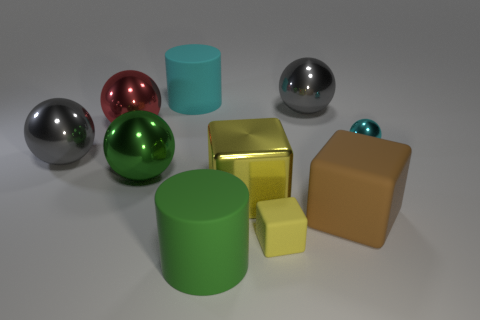What can you infer about the light source in this image? The light source in the image is likely positioned above and to the right, as indicated by the highlights and shadows on the objects. The reflections on the spheres suggest a single, strong light source. 